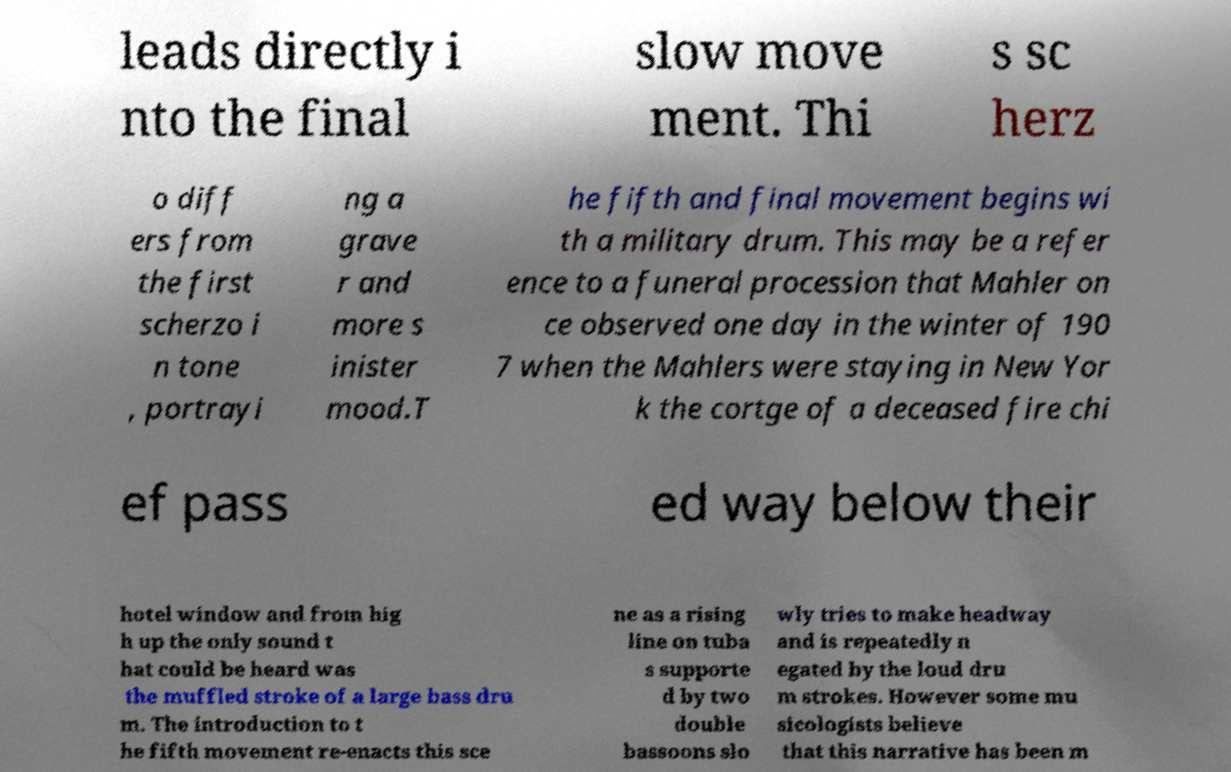What messages or text are displayed in this image? I need them in a readable, typed format. leads directly i nto the final slow move ment. Thi s sc herz o diff ers from the first scherzo i n tone , portrayi ng a grave r and more s inister mood.T he fifth and final movement begins wi th a military drum. This may be a refer ence to a funeral procession that Mahler on ce observed one day in the winter of 190 7 when the Mahlers were staying in New Yor k the cortge of a deceased fire chi ef pass ed way below their hotel window and from hig h up the only sound t hat could be heard was the muffled stroke of a large bass dru m. The introduction to t he fifth movement re-enacts this sce ne as a rising line on tuba s supporte d by two double bassoons slo wly tries to make headway and is repeatedly n egated by the loud dru m strokes. However some mu sicologists believe that this narrative has been m 